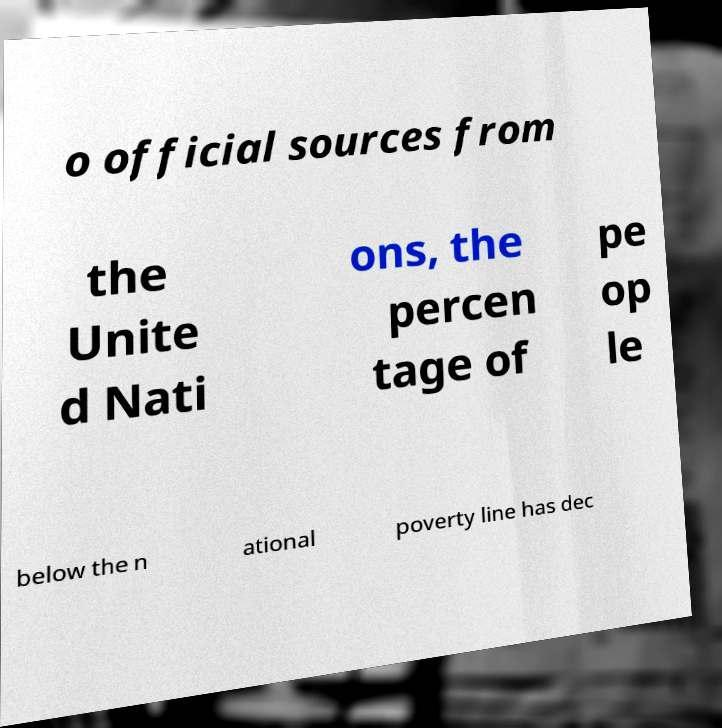There's text embedded in this image that I need extracted. Can you transcribe it verbatim? o official sources from the Unite d Nati ons, the percen tage of pe op le below the n ational poverty line has dec 